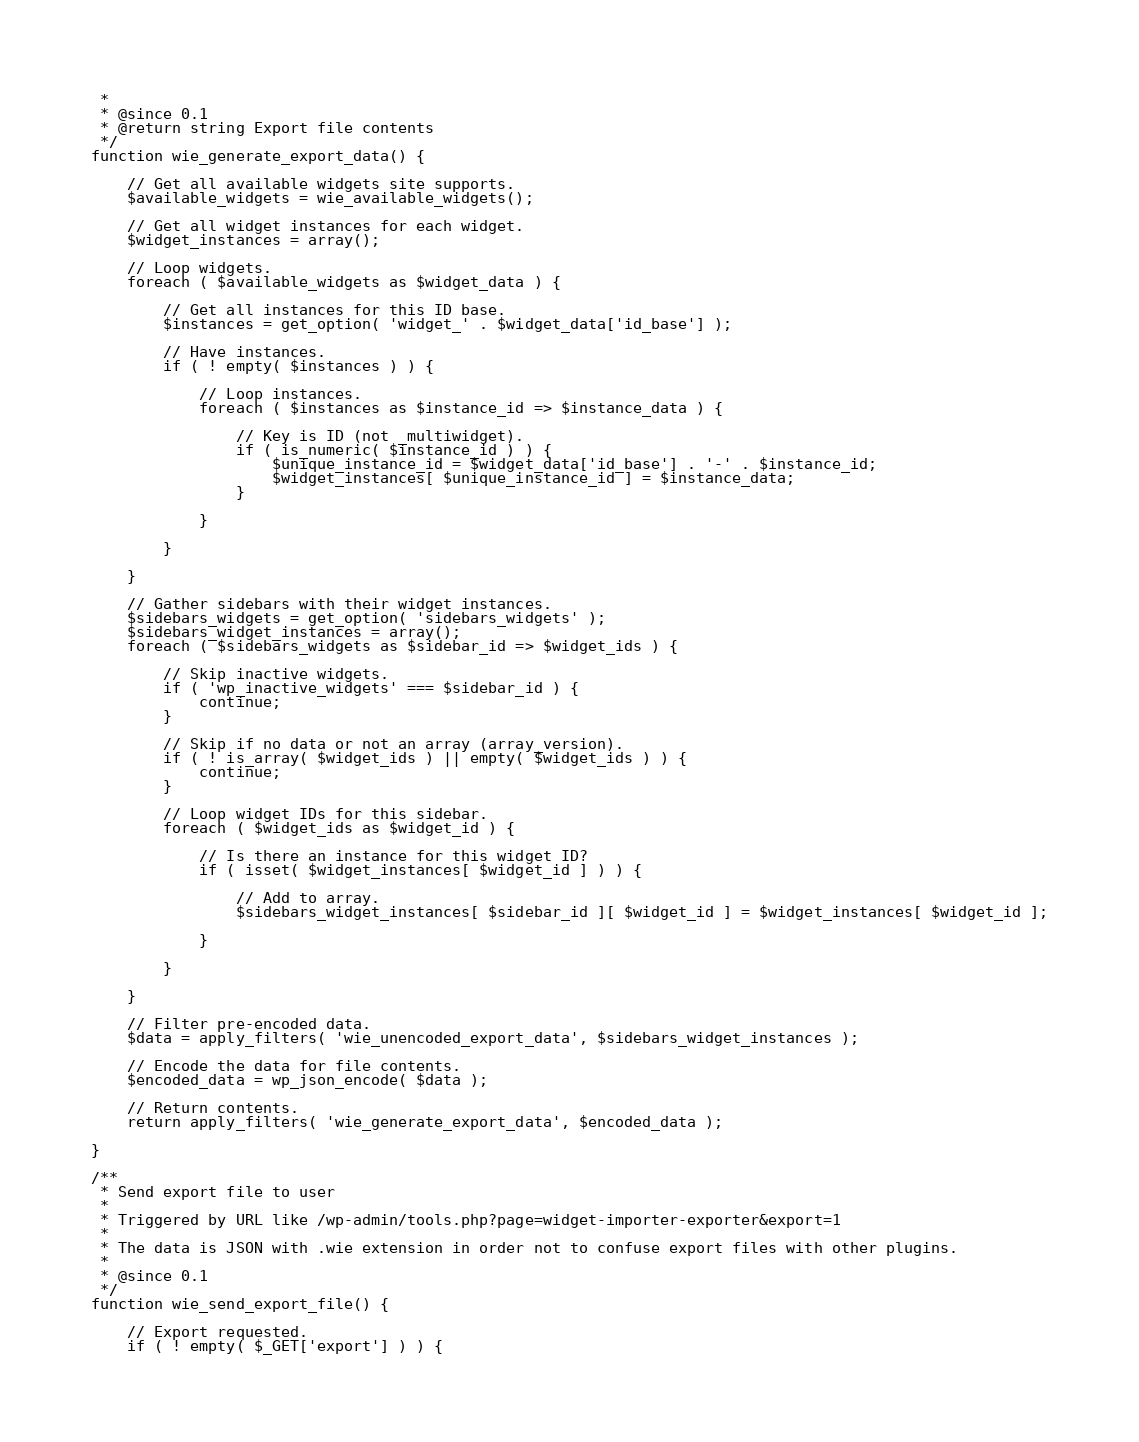Convert code to text. <code><loc_0><loc_0><loc_500><loc_500><_PHP_> *
 * @since 0.1
 * @return string Export file contents
 */
function wie_generate_export_data() {

	// Get all available widgets site supports.
	$available_widgets = wie_available_widgets();

	// Get all widget instances for each widget.
	$widget_instances = array();

	// Loop widgets.
	foreach ( $available_widgets as $widget_data ) {

		// Get all instances for this ID base.
		$instances = get_option( 'widget_' . $widget_data['id_base'] );

		// Have instances.
		if ( ! empty( $instances ) ) {

			// Loop instances.
			foreach ( $instances as $instance_id => $instance_data ) {

				// Key is ID (not _multiwidget).
				if ( is_numeric( $instance_id ) ) {
					$unique_instance_id = $widget_data['id_base'] . '-' . $instance_id;
					$widget_instances[ $unique_instance_id ] = $instance_data;
				}

			}

		}

	}

	// Gather sidebars with their widget instances.
	$sidebars_widgets = get_option( 'sidebars_widgets' );
	$sidebars_widget_instances = array();
	foreach ( $sidebars_widgets as $sidebar_id => $widget_ids ) {

		// Skip inactive widgets.
		if ( 'wp_inactive_widgets' === $sidebar_id ) {
			continue;
		}

		// Skip if no data or not an array (array_version).
		if ( ! is_array( $widget_ids ) || empty( $widget_ids ) ) {
			continue;
		}

		// Loop widget IDs for this sidebar.
		foreach ( $widget_ids as $widget_id ) {

			// Is there an instance for this widget ID?
			if ( isset( $widget_instances[ $widget_id ] ) ) {

				// Add to array.
				$sidebars_widget_instances[ $sidebar_id ][ $widget_id ] = $widget_instances[ $widget_id ];

			}

		}

	}

	// Filter pre-encoded data.
	$data = apply_filters( 'wie_unencoded_export_data', $sidebars_widget_instances );

	// Encode the data for file contents.
	$encoded_data = wp_json_encode( $data );

	// Return contents.
	return apply_filters( 'wie_generate_export_data', $encoded_data );

}

/**
 * Send export file to user
 *
 * Triggered by URL like /wp-admin/tools.php?page=widget-importer-exporter&export=1
 *
 * The data is JSON with .wie extension in order not to confuse export files with other plugins.
 *
 * @since 0.1
 */
function wie_send_export_file() {

	// Export requested.
	if ( ! empty( $_GET['export'] ) ) {
</code> 